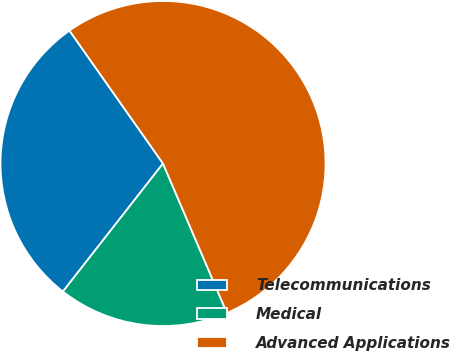<chart> <loc_0><loc_0><loc_500><loc_500><pie_chart><fcel>Telecommunications<fcel>Medical<fcel>Advanced Applications<nl><fcel>29.68%<fcel>16.99%<fcel>53.33%<nl></chart> 